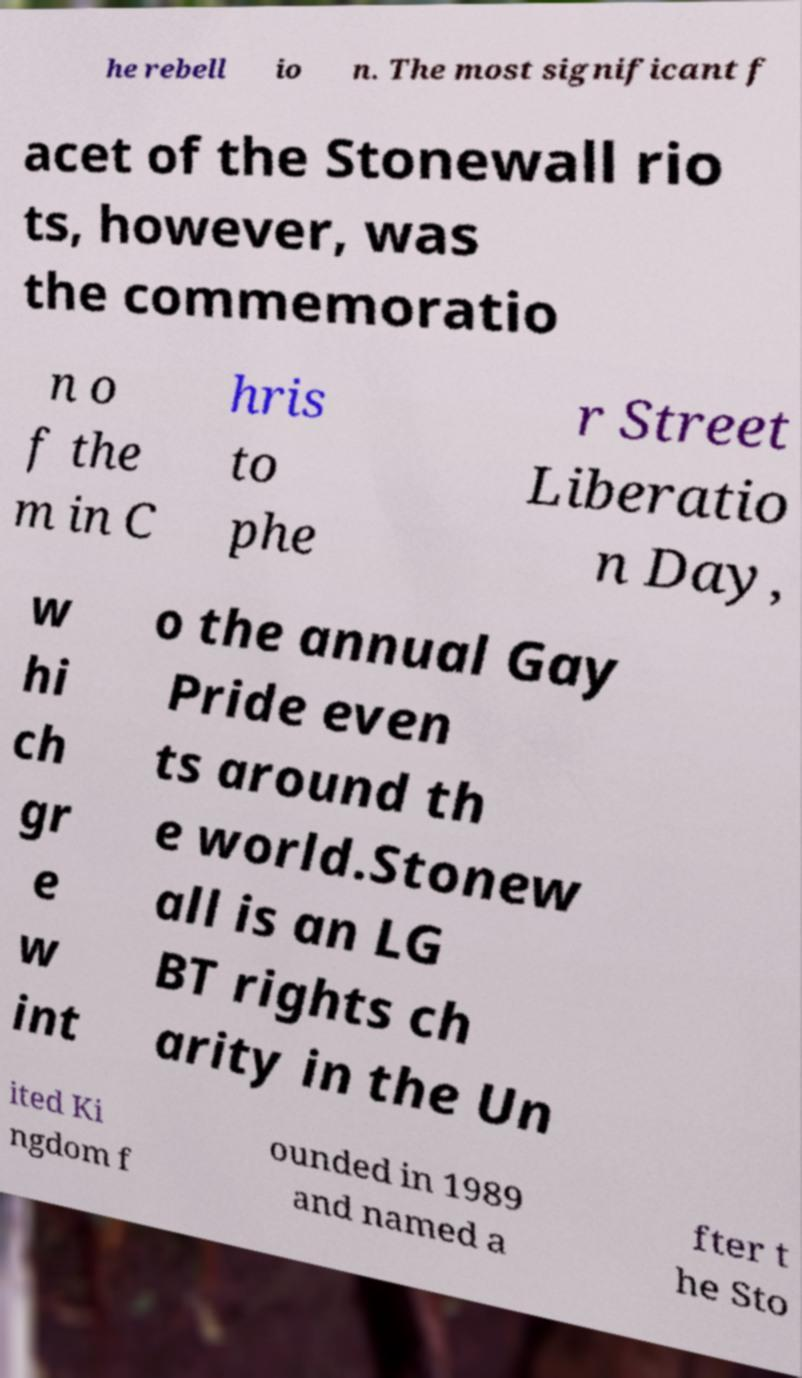Can you read and provide the text displayed in the image?This photo seems to have some interesting text. Can you extract and type it out for me? he rebell io n. The most significant f acet of the Stonewall rio ts, however, was the commemoratio n o f the m in C hris to phe r Street Liberatio n Day, w hi ch gr e w int o the annual Gay Pride even ts around th e world.Stonew all is an LG BT rights ch arity in the Un ited Ki ngdom f ounded in 1989 and named a fter t he Sto 